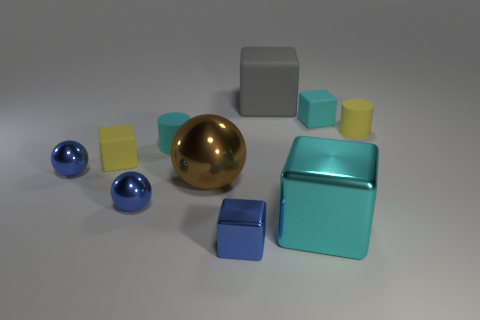There is a cylinder that is the same color as the large metallic cube; what is its material?
Provide a succinct answer. Rubber. How many other objects are the same material as the tiny yellow cube?
Your response must be concise. 4. Do the big brown metallic object and the big rubber object that is on the left side of the cyan metal block have the same shape?
Keep it short and to the point. No. What shape is the cyan object that is made of the same material as the tiny cyan block?
Provide a succinct answer. Cylinder. Is the number of cyan matte cylinders that are behind the gray rubber block greater than the number of things to the right of the large brown metal object?
Offer a terse response. No. What number of objects are small cylinders or tiny matte balls?
Your answer should be compact. 2. What number of other objects are there of the same color as the large rubber thing?
Your answer should be compact. 0. There is a brown thing that is the same size as the gray thing; what shape is it?
Your answer should be compact. Sphere. There is a rubber object right of the tiny cyan cube; what is its color?
Your answer should be compact. Yellow. What number of objects are either objects that are on the right side of the small blue block or cyan blocks that are behind the tiny yellow rubber cylinder?
Your answer should be very brief. 4. 